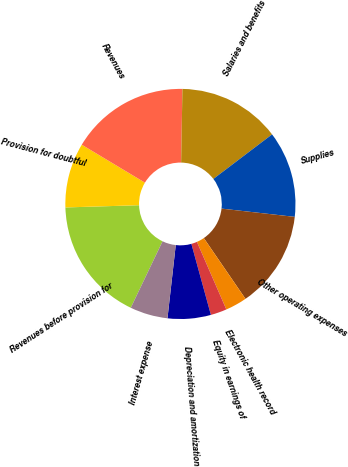<chart> <loc_0><loc_0><loc_500><loc_500><pie_chart><fcel>Revenues before provision for<fcel>Provision for doubtful<fcel>Revenues<fcel>Salaries and benefits<fcel>Supplies<fcel>Other operating expenses<fcel>Electronic health record<fcel>Equity in earnings of<fcel>Depreciation and amortization<fcel>Interest expense<nl><fcel>17.42%<fcel>9.09%<fcel>16.67%<fcel>14.39%<fcel>12.12%<fcel>13.64%<fcel>3.03%<fcel>2.27%<fcel>6.06%<fcel>5.3%<nl></chart> 